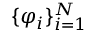Convert formula to latex. <formula><loc_0><loc_0><loc_500><loc_500>\{ \varphi _ { i } \} _ { i = 1 } ^ { N }</formula> 